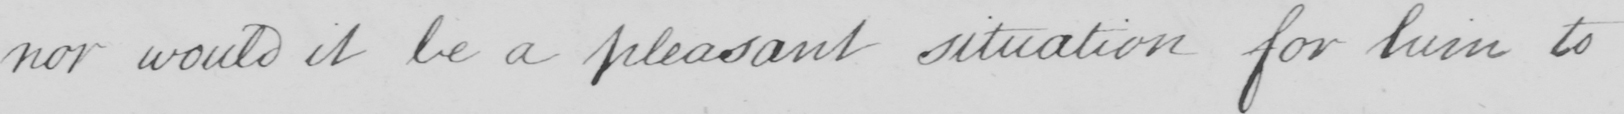What text is written in this handwritten line? nor would it be a pleasant situation for him to 